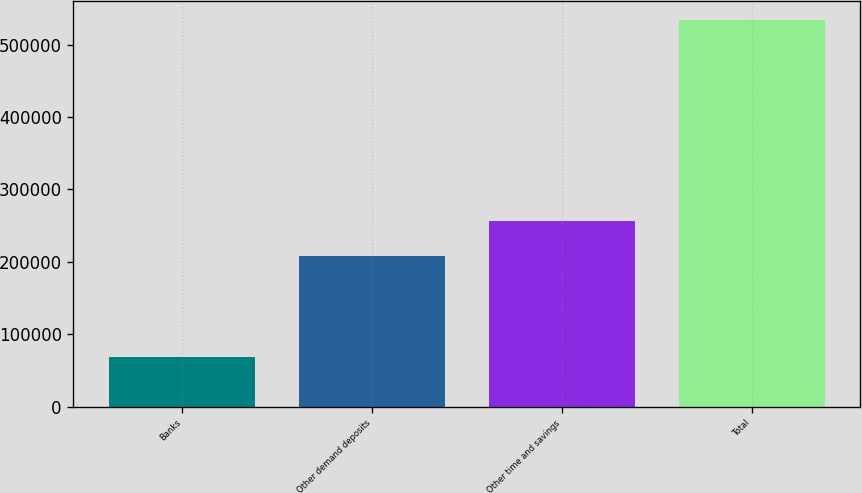Convert chart. <chart><loc_0><loc_0><loc_500><loc_500><bar_chart><fcel>Banks<fcel>Other demand deposits<fcel>Other time and savings<fcel>Total<nl><fcel>68538<fcel>208634<fcel>256946<fcel>534118<nl></chart> 